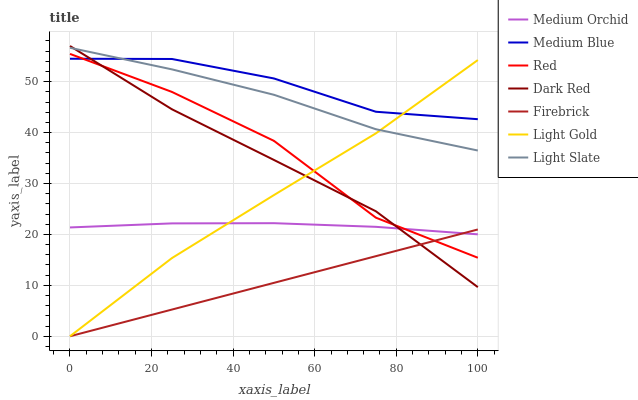Does Firebrick have the minimum area under the curve?
Answer yes or no. Yes. Does Medium Blue have the maximum area under the curve?
Answer yes or no. Yes. Does Dark Red have the minimum area under the curve?
Answer yes or no. No. Does Dark Red have the maximum area under the curve?
Answer yes or no. No. Is Firebrick the smoothest?
Answer yes or no. Yes. Is Red the roughest?
Answer yes or no. Yes. Is Dark Red the smoothest?
Answer yes or no. No. Is Dark Red the roughest?
Answer yes or no. No. Does Firebrick have the lowest value?
Answer yes or no. Yes. Does Dark Red have the lowest value?
Answer yes or no. No. Does Dark Red have the highest value?
Answer yes or no. Yes. Does Firebrick have the highest value?
Answer yes or no. No. Is Red less than Light Slate?
Answer yes or no. Yes. Is Medium Blue greater than Medium Orchid?
Answer yes or no. Yes. Does Firebrick intersect Light Gold?
Answer yes or no. Yes. Is Firebrick less than Light Gold?
Answer yes or no. No. Is Firebrick greater than Light Gold?
Answer yes or no. No. Does Red intersect Light Slate?
Answer yes or no. No. 